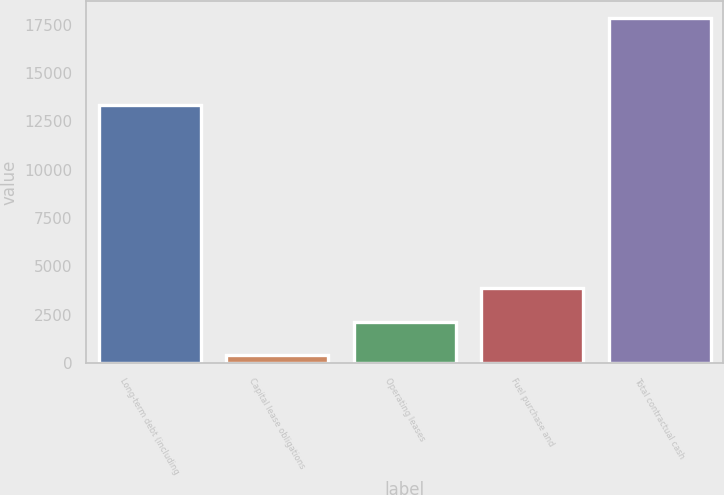Convert chart. <chart><loc_0><loc_0><loc_500><loc_500><bar_chart><fcel>Long-term debt (including<fcel>Capital lease obligations<fcel>Operating leases<fcel>Fuel purchase and<fcel>Total contractual cash<nl><fcel>13348<fcel>403<fcel>2145.1<fcel>3887.2<fcel>17824<nl></chart> 